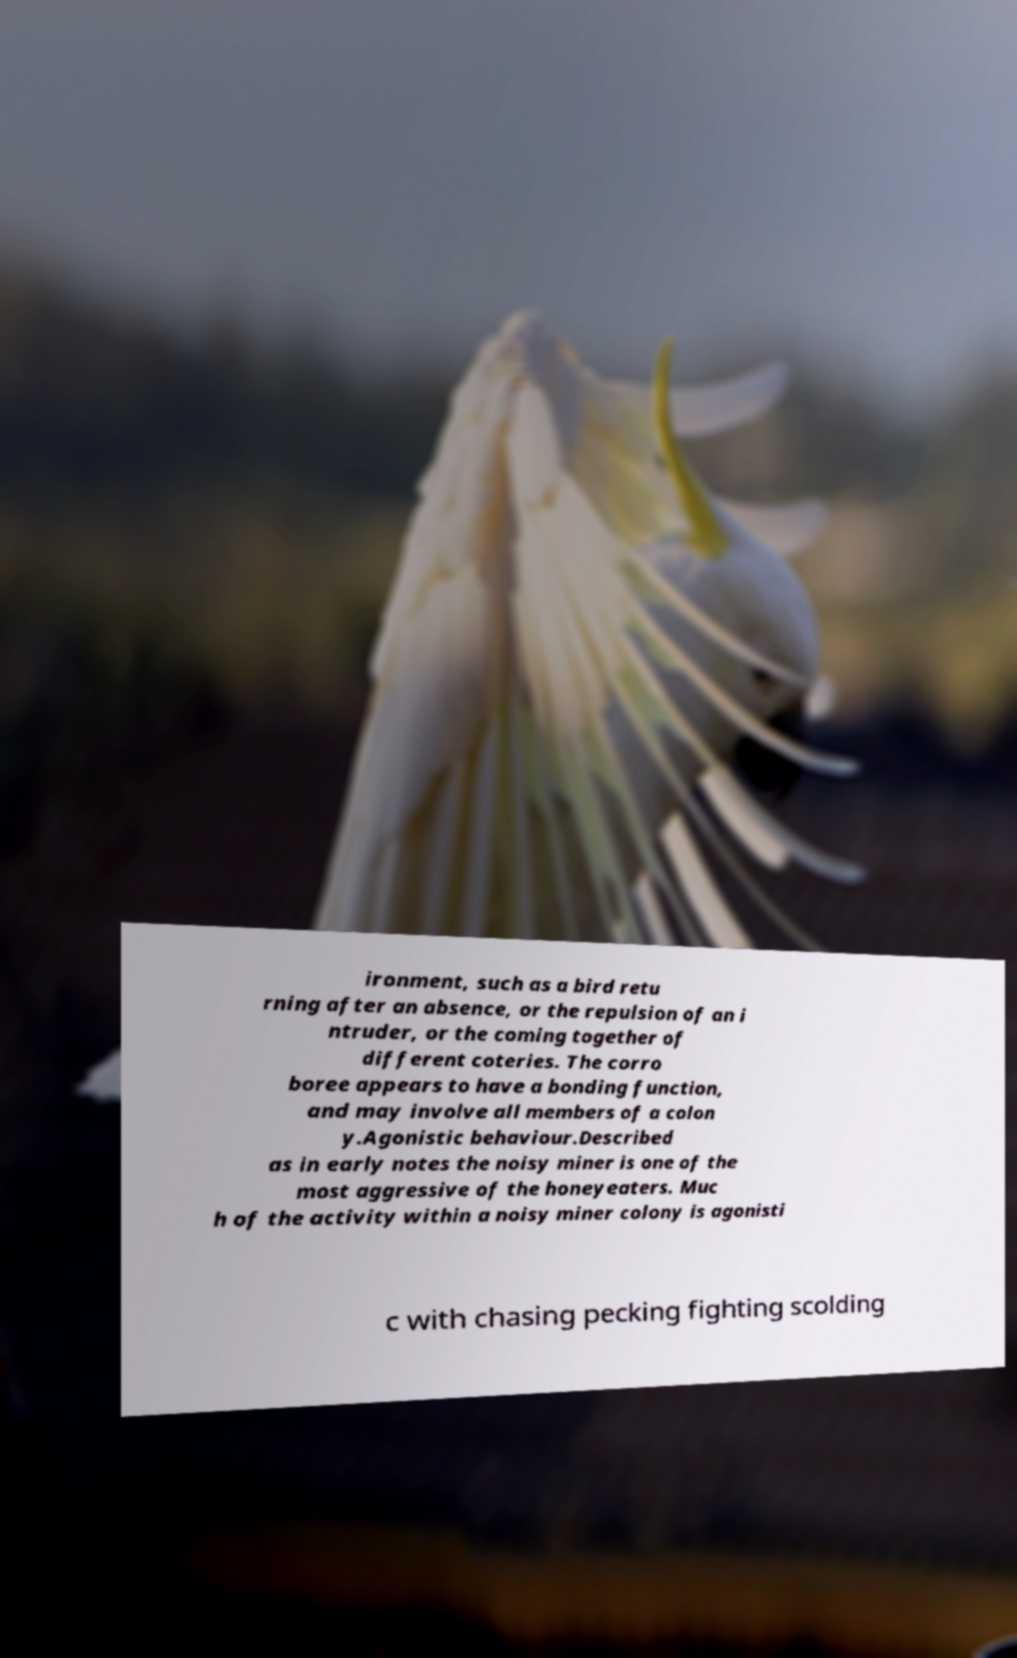Could you assist in decoding the text presented in this image and type it out clearly? ironment, such as a bird retu rning after an absence, or the repulsion of an i ntruder, or the coming together of different coteries. The corro boree appears to have a bonding function, and may involve all members of a colon y.Agonistic behaviour.Described as in early notes the noisy miner is one of the most aggressive of the honeyeaters. Muc h of the activity within a noisy miner colony is agonisti c with chasing pecking fighting scolding 